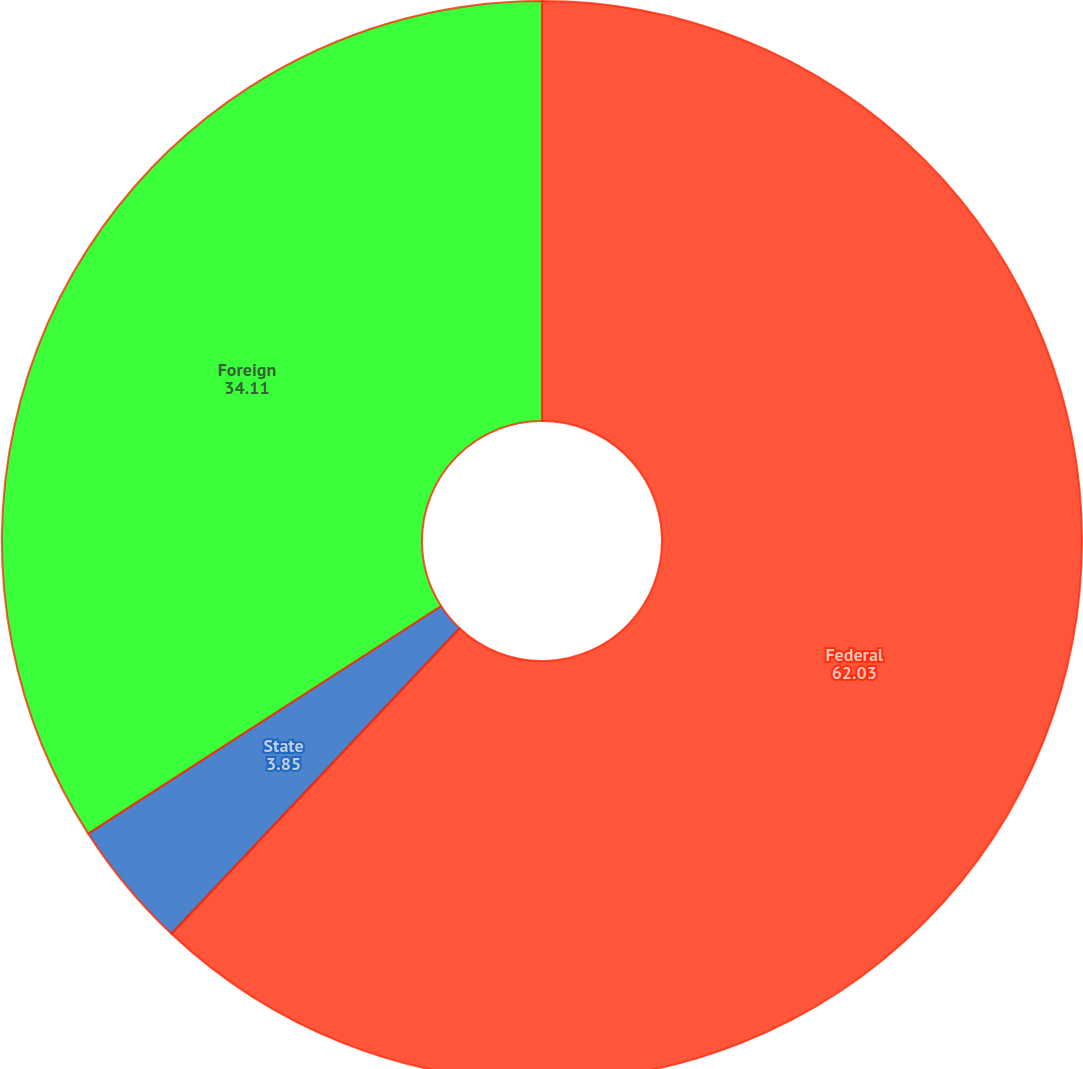Convert chart to OTSL. <chart><loc_0><loc_0><loc_500><loc_500><pie_chart><fcel>Federal<fcel>State<fcel>Foreign<nl><fcel>62.03%<fcel>3.85%<fcel>34.11%<nl></chart> 